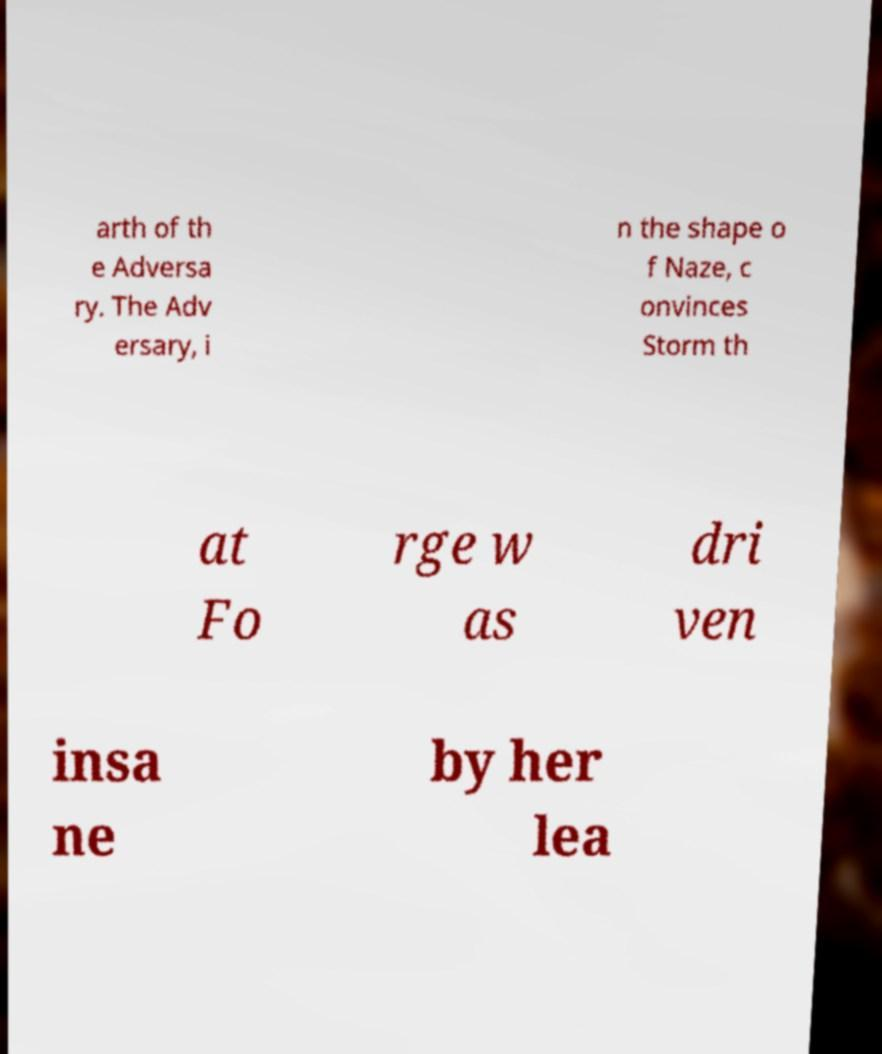Can you accurately transcribe the text from the provided image for me? arth of th e Adversa ry. The Adv ersary, i n the shape o f Naze, c onvinces Storm th at Fo rge w as dri ven insa ne by her lea 